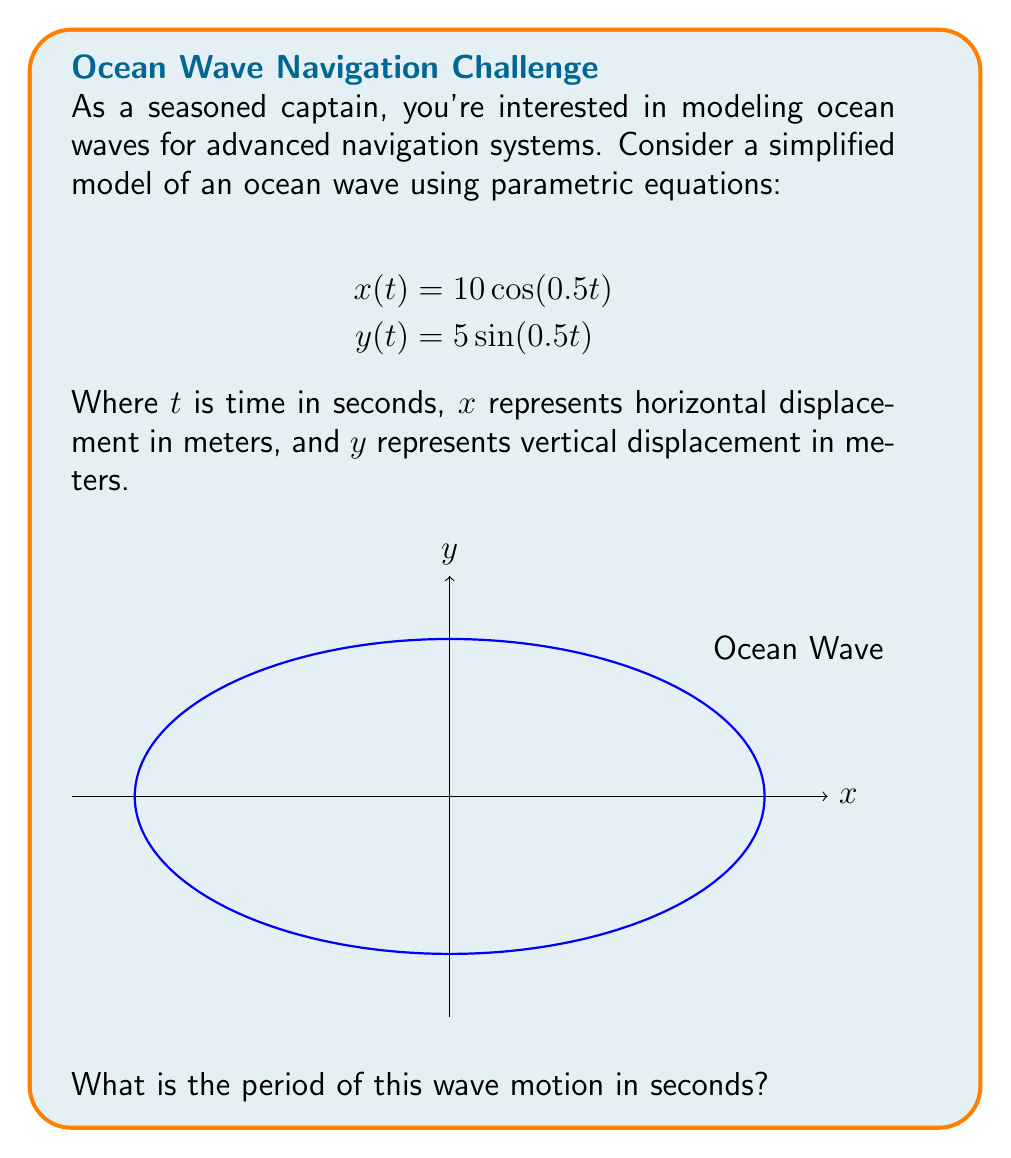Can you answer this question? To find the period of the wave motion, we need to determine how long it takes for the wave to complete one full cycle. Let's approach this step-by-step:

1) The period is the time it takes for both $x(t)$ and $y(t)$ to complete one full cycle.

2) For the cosine function in $x(t)$:
   $$x(t) = 10\cos(0.5t)$$
   The general form of a cosine function is $\cos(\omega t)$, where $\omega$ is the angular frequency.
   Here, $\omega = 0.5$ rad/s.

3) The period of a cosine (or sine) function is given by:
   $$T = \frac{2\pi}{\omega}$$

4) Substituting $\omega = 0.5$:
   $$T = \frac{2\pi}{0.5} = 4\pi$$

5) Therefore, the period of the wave motion is $4\pi$ seconds.

This means that every $4\pi$ seconds (approximately 12.57 seconds), the wave will complete one full cycle and return to its starting position.
Answer: $4\pi$ seconds 